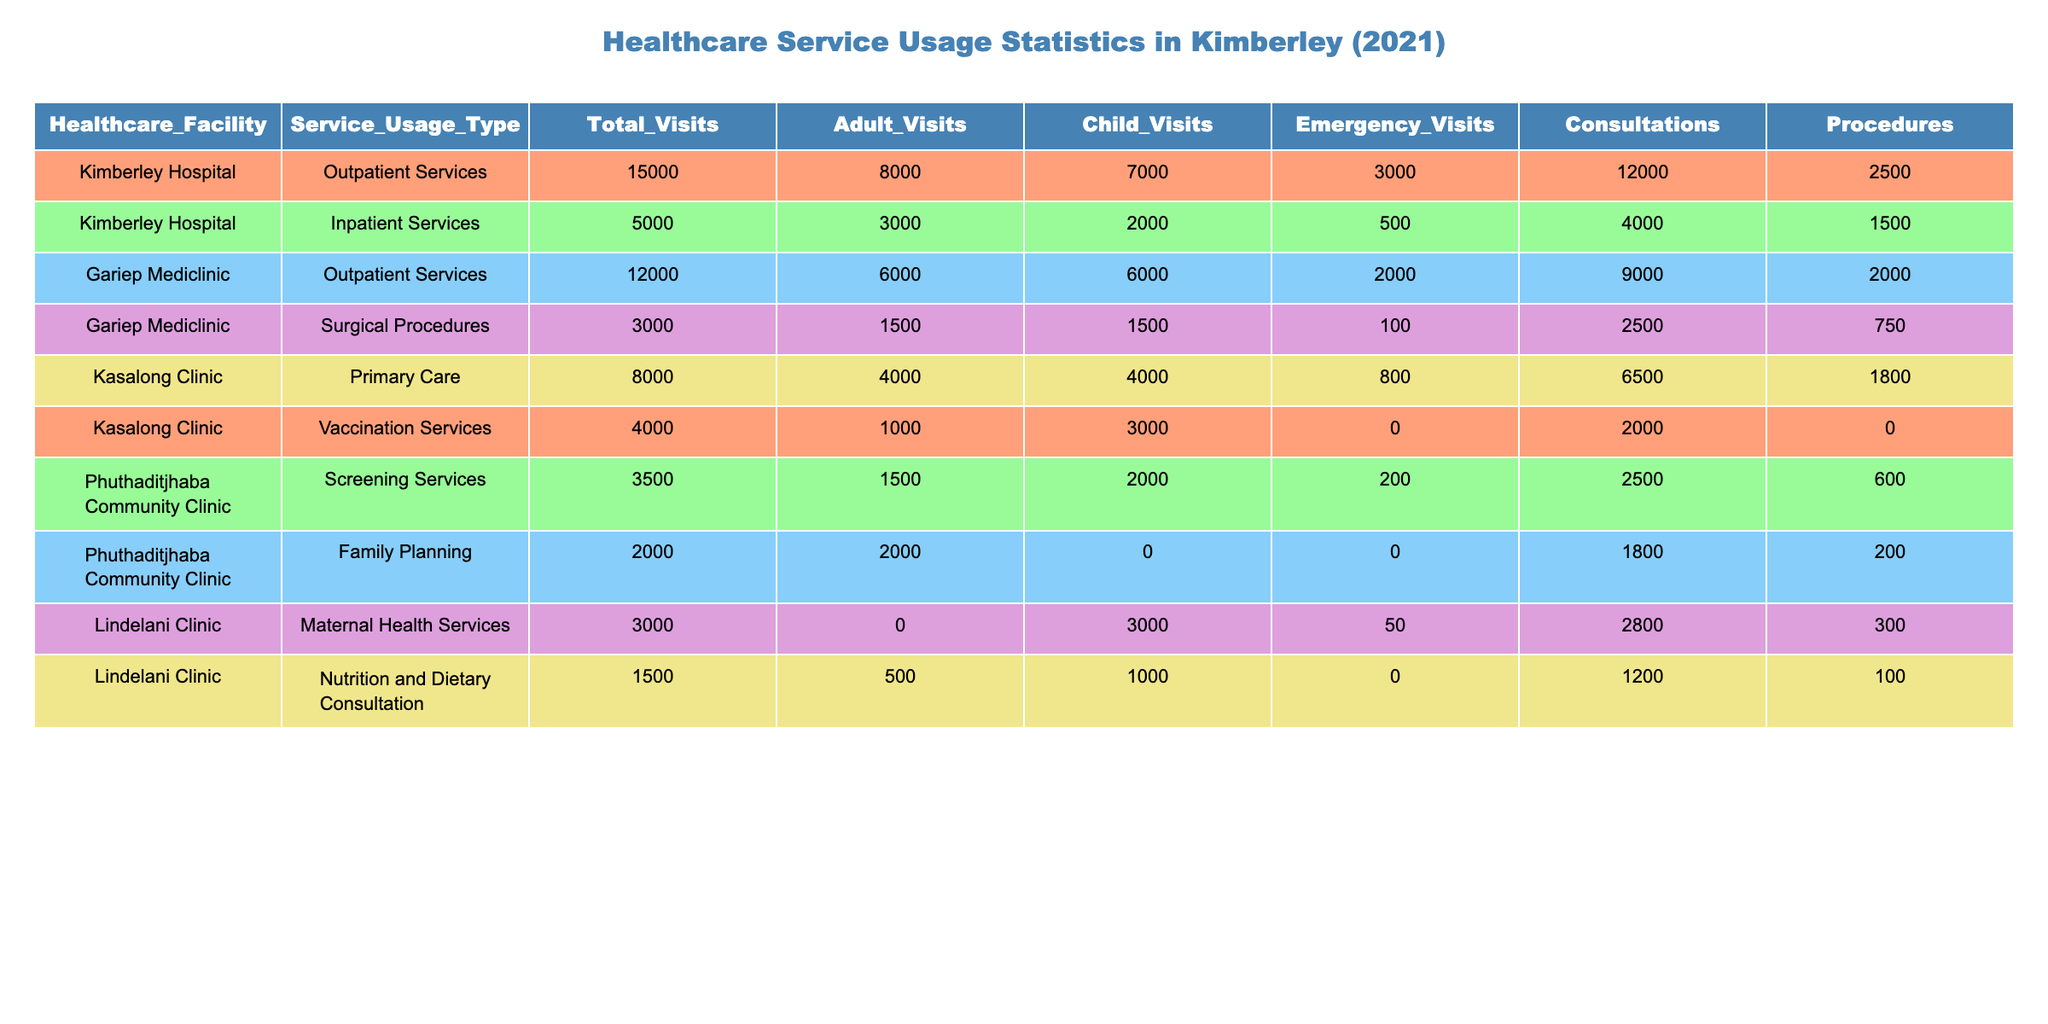What is the total number of visits to Kimberley Hospital for outpatient services? The table lists Kimberley Hospital under outpatient services with a total of 15,000 visits.
Answer: 15,000 How many total visits were made to Gariep Mediclinic for surgical procedures? According to the table, Gariep Mediclinic had 3,000 total visits for surgical procedures.
Answer: 3,000 Which healthcare facility had the highest number of adult visits? By examining the total adult visits, Kimberley Hospital for outpatient services had 8,000 adult visits, which is the highest among the listed facilities.
Answer: Kimberley Hospital What is the percentage of child visits at Kasalong Clinic for primary care? The total visits to Kasalong Clinic for primary care were 8,000, and child visits were 4,000. The percentage of child visits is (4,000 / 8,000) * 100 = 50%.
Answer: 50% What is the total number of emergency visits across all facilities? Summing the emergency visits from all facilities: 3,000 (Kimberley Hospital) + 500 (Kimberley Hospital inpatient) + 2,000 (Gariep Mediclinic outpatient) + 100 (Gariep Mediclinic surgical) + 800 (Kasalong Clinic) + 0 (Kasalong vaccination) + 200 (Phuthaditjhaba screening) + 0 (Phuthaditjhaba family planning) + 50 (Lindelani maternal health) = 6,650 emergency visits in total.
Answer: 6,650 Does Lindelani Clinic provide any outpatient services? According to the table, Lindelani Clinic does not have any outpatient services listed; instead, it only provides maternal health services and nutrition consultations.
Answer: No Which service type had the highest total procedure count in Lindelani Clinic? The table shows that maternal health services had a total of 300 procedures and nutrition and dietary consultation had 100 procedures. Thus, maternal health services had the highest count.
Answer: Maternal Health Services How do the total outpatient visits in Kimberley Hospital compare to those in Gariep Mediclinic? Kimberley Hospital had 15,000 outpatient visits, whereas Gariep Mediclinic had 12,000. The difference is 15,000 - 12,000 = 3,000 more visits at Kimberley Hospital than Gariep Mediclinic.
Answer: Kimberley Hospital has 3,000 more visits What is the total number of visits for vaccination services compared to primary care at Kasalong Clinic? Kasalong Clinic had 4,000 visits for vaccination services and 8,000 for primary care. Thus, primary care had 4,000 more visits than vaccination services.
Answer: Primary care had 4,000 more visits What is the total visit count for Phuthaditjhaba Community Clinic? The total visits for Phuthaditjhaba Community Clinic are 3,500 (screening) + 2,000 (family planning) = 5,500 total visits.
Answer: 5,500 Which facility had more total consultations, Gariep Mediclinic or Kasalong Clinic? Gariep Mediclinic had a total of 9,000 consultations (from outpatient) and 2,500 (from surgical) for a combined total of 11,500 consultations, while Kasalong Clinic had 6,500 (from primary care) plus 2,000 (from vaccination) for a total of 8,500. Therefore, Gariep Mediclinic had more consultations.
Answer: Gariep Mediclinic had more consultations 